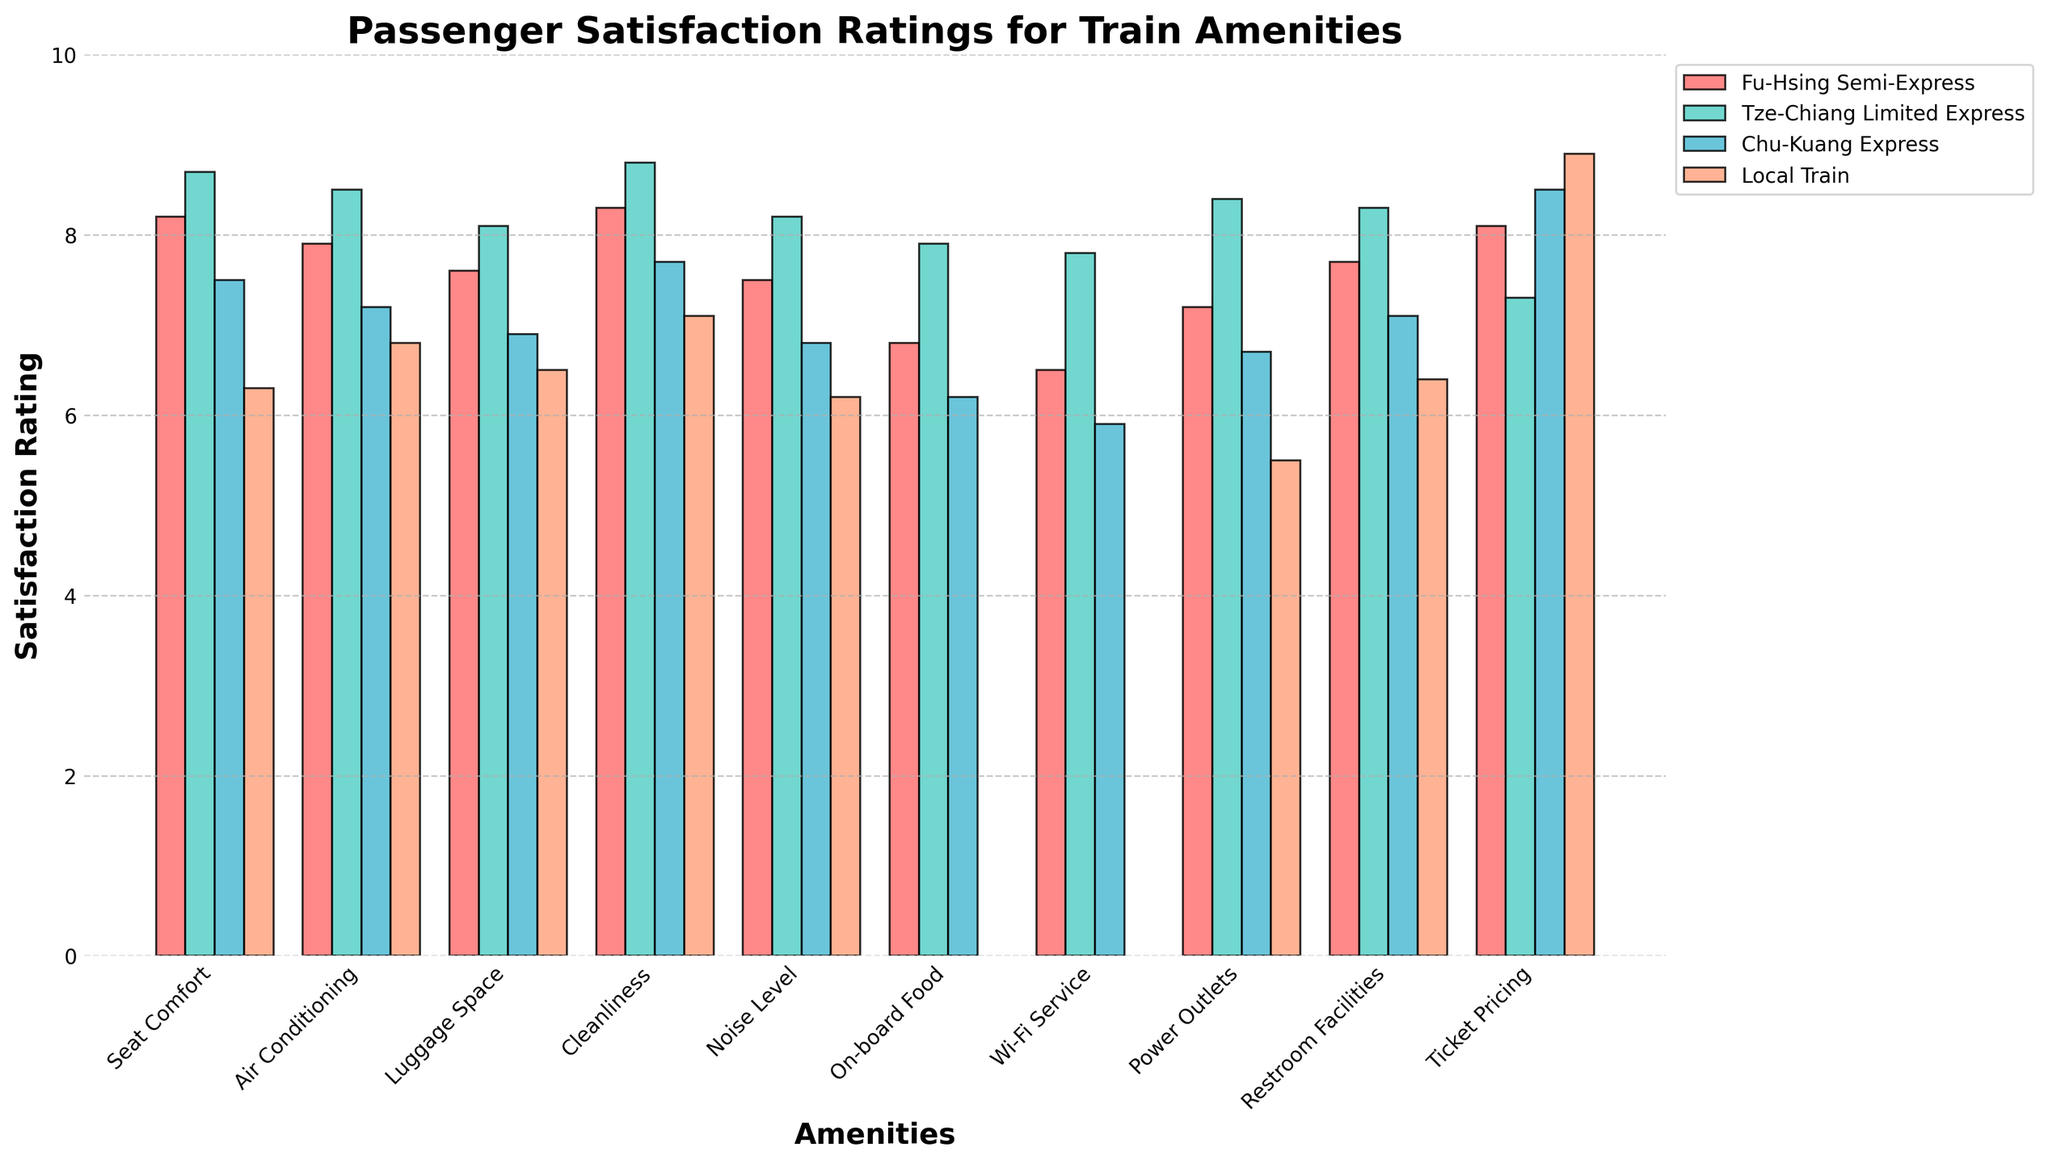Which train type has the highest satisfaction for Seat Comfort? By visually inspecting the bar heights for Seat Comfort, the Tze-Chiang Limited Express has the tallest bar, indicating the highest satisfaction rating.
Answer: Tze-Chiang Limited Express Which amenity has the lowest satisfaction rating for the Fu-Hsing Semi-Express? Look at the lowest bar height among Fu-Hsing Semi-Express amenities. Wi-Fi Service has the lowest rating.
Answer: Wi-Fi Service What is the average satisfaction rating for Cleanliness across all train types? Add the satisfaction ratings for Cleanliness for all train types and divide by the number of train types (8.3 + 8.8 + 7.7 + 7.1) / 4.
Answer: 7.98 How much higher is the satisfaction rating for Restroom Facilities in the Tze-Chiang Limited Express compared to the Local Train? Subtract the satisfaction rating for Restroom Facilities in the Local Train from that in the Tze-Chiang Limited Express (8.3 - 6.4).
Answer: 1.9 Which train type has the most evenly distributed satisfaction ratings across all amenities? By visually inspecting the bar heights for each train type, the Fu-Hsing Semi-Express and Tze-Chiang Limited Express have relatively even bar heights, but more notably Fu-Hsing Semi-Express shows no drastic variations.
Answer: Fu-Hsing Semi-Express Considering the Fu-Hsing Semi-Express, which amenity shows the greatest difference in satisfaction rating compared to Tze-Chiang Limited Express, and what is that difference? Calculate the absolute differences in satisfaction ratings for each amenity between Fu-Hsing Semi-Express and Tze-Chiang Limited Express. The greatest difference is for Seat Comfort (8.7 - 8.2 = 0.5).
Answer: Seat Comfort, 0.5 Which two amenities have the closest satisfaction ratings for the Fu-Hsing Semi-Express? Compare the satisfaction ratings of amenities for the Fu-Hsing Semi-Express to find the closest values. Seat Comfort (8.2) and Ticket Pricing (8.1) are the closest.
Answer: Seat Comfort and Ticket Pricing For the Chu-Kuang Express, which amenity has a satisfaction rating closest to the average rating of all its amenities? Calculate the average rating of all amenities for Chu-Kuang Express [(7.5 + 7.2 + 6.9 + 7.7 + 6.8 + 6.2 + 5.9 + 6.7 + 7.1 + 8.5) / 10 = 7.05] and then identify the closest individual amenity rating (Luggage Space with 6.9).
Answer: Luggage Space What is the difference in satisfaction rating for Air Conditioning between Fu-Hsing Semi-Express and Chu-Kuang Express? Subtract the satisfaction rating for Chu-Kuang Express from Fu-Hsing Semi-Express for Air Conditioning (7.9 - 7.2).
Answer: 0.7 Which amenity has the widest range of satisfaction ratings across all train types? Find the range (max - min) for each amenity. On-board Food has the widest range (7.9 - 6.2 = 1.7).
Answer: On-board Food 